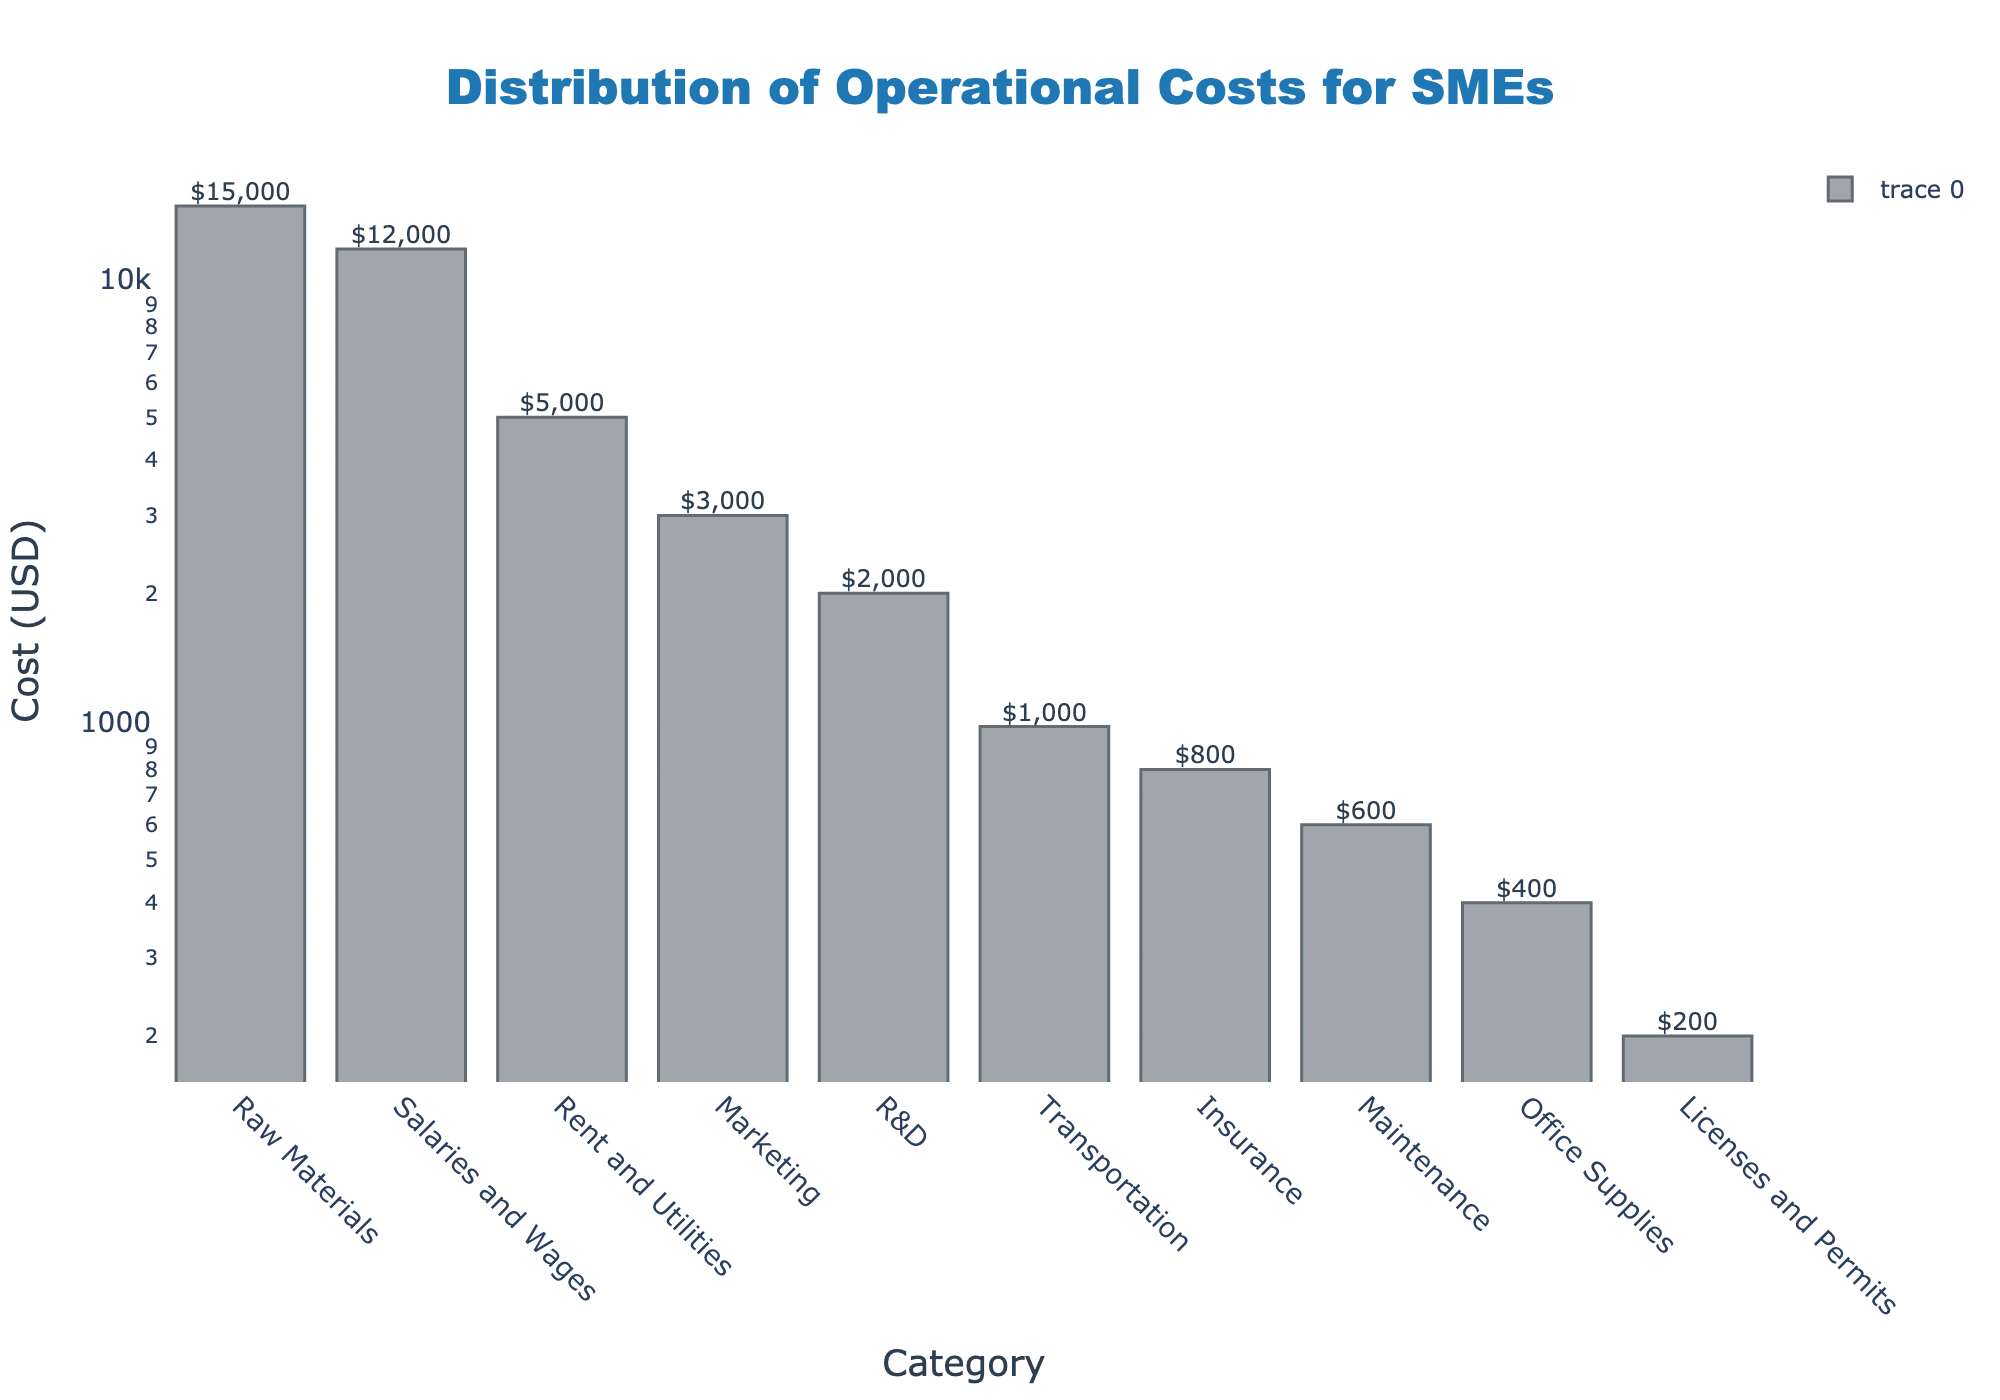What is the highest cost category in the figure? The highest cost category is the one with the tallest bar in the bar plot. From the figure, the category "Raw Materials" has the highest cost.
Answer: Raw Materials How many categories have costs greater than \$1,000? By examining the y-axis (log scale), we can see how many categories have bars above the \$1,000 mark. The categories "Raw Materials," "Salaries and Wages," "Rent and Utilities," "Marketing," and "R&D" all have costs greater than \$1,000.
Answer: 5 What is the smallest cost category in the figure? The smallest cost category is the one with the shortest bar in the bar plot. From the figure, the category "Licenses and Permits" has the smallest cost.
Answer: Licenses and Permits How does the cost of Marketing compare to the cost of Transportation? By looking at the bars representing the costs for "Marketing" and "Transportation," we see the height of the "Marketing" bar is higher than that of the "Transportation" bar, indicating that Marketing costs more.
Answer: Marketing costs more Sum the costs of "Maintenance," "Office Supplies," and "Licenses and Permits." To sum the costs of these three categories, refer to the heights of their respective bars: Maintenance (\$600), Office Supplies (\$400), and Licenses and Permits (\$200). The total cost is \$600 + \$400 + \$200 = \$1,200.
Answer: \$1,200 What is the median cost from all the categories? To find the median cost, first list the costs in ascending order: \$200, \$400, \$600, \$800, \$1,000, \$2,000, \$3,000, \$5,000, \$12,000, \$15,000. The median cost here would be the average of the 5th and 6th values: (\$1,000 + \$2,000) / 2 = \$1,500.
Answer: \$1,500 Which category has a cost that is half of "Rent and Utilities"? The cost of "Rent and Utilities" is \$5,000. Looking for a category with half of that cost, \$5,000 / 2 = \$2,500, we find it matches none exactly but the closest category is "R&D" with \$2,000.
Answer: R&D What are the colors used to represent the bars in the plot? The bars in the plot are colored in a semi-transparent dark blue shade, with a darker outline.
Answer: Dark blue shade How does the cost of R&D compare with the cost of Insurance? By comparing the heights of the "R&D" and "Insurance" bars, the bar representing "R&D" is higher, indicating that R&D costs more than Insurance.
Answer: R&D costs more What is the total cost of the top three cost categories? The top three cost categories are "Raw Materials" (\$15,000), "Salaries and Wages" (\$12,000), and "Rent and Utilities" (\$5,000). Adding these costs: \$15,000 + \$12,000 + \$5,000 = \$32,000.
Answer: \$32,000 